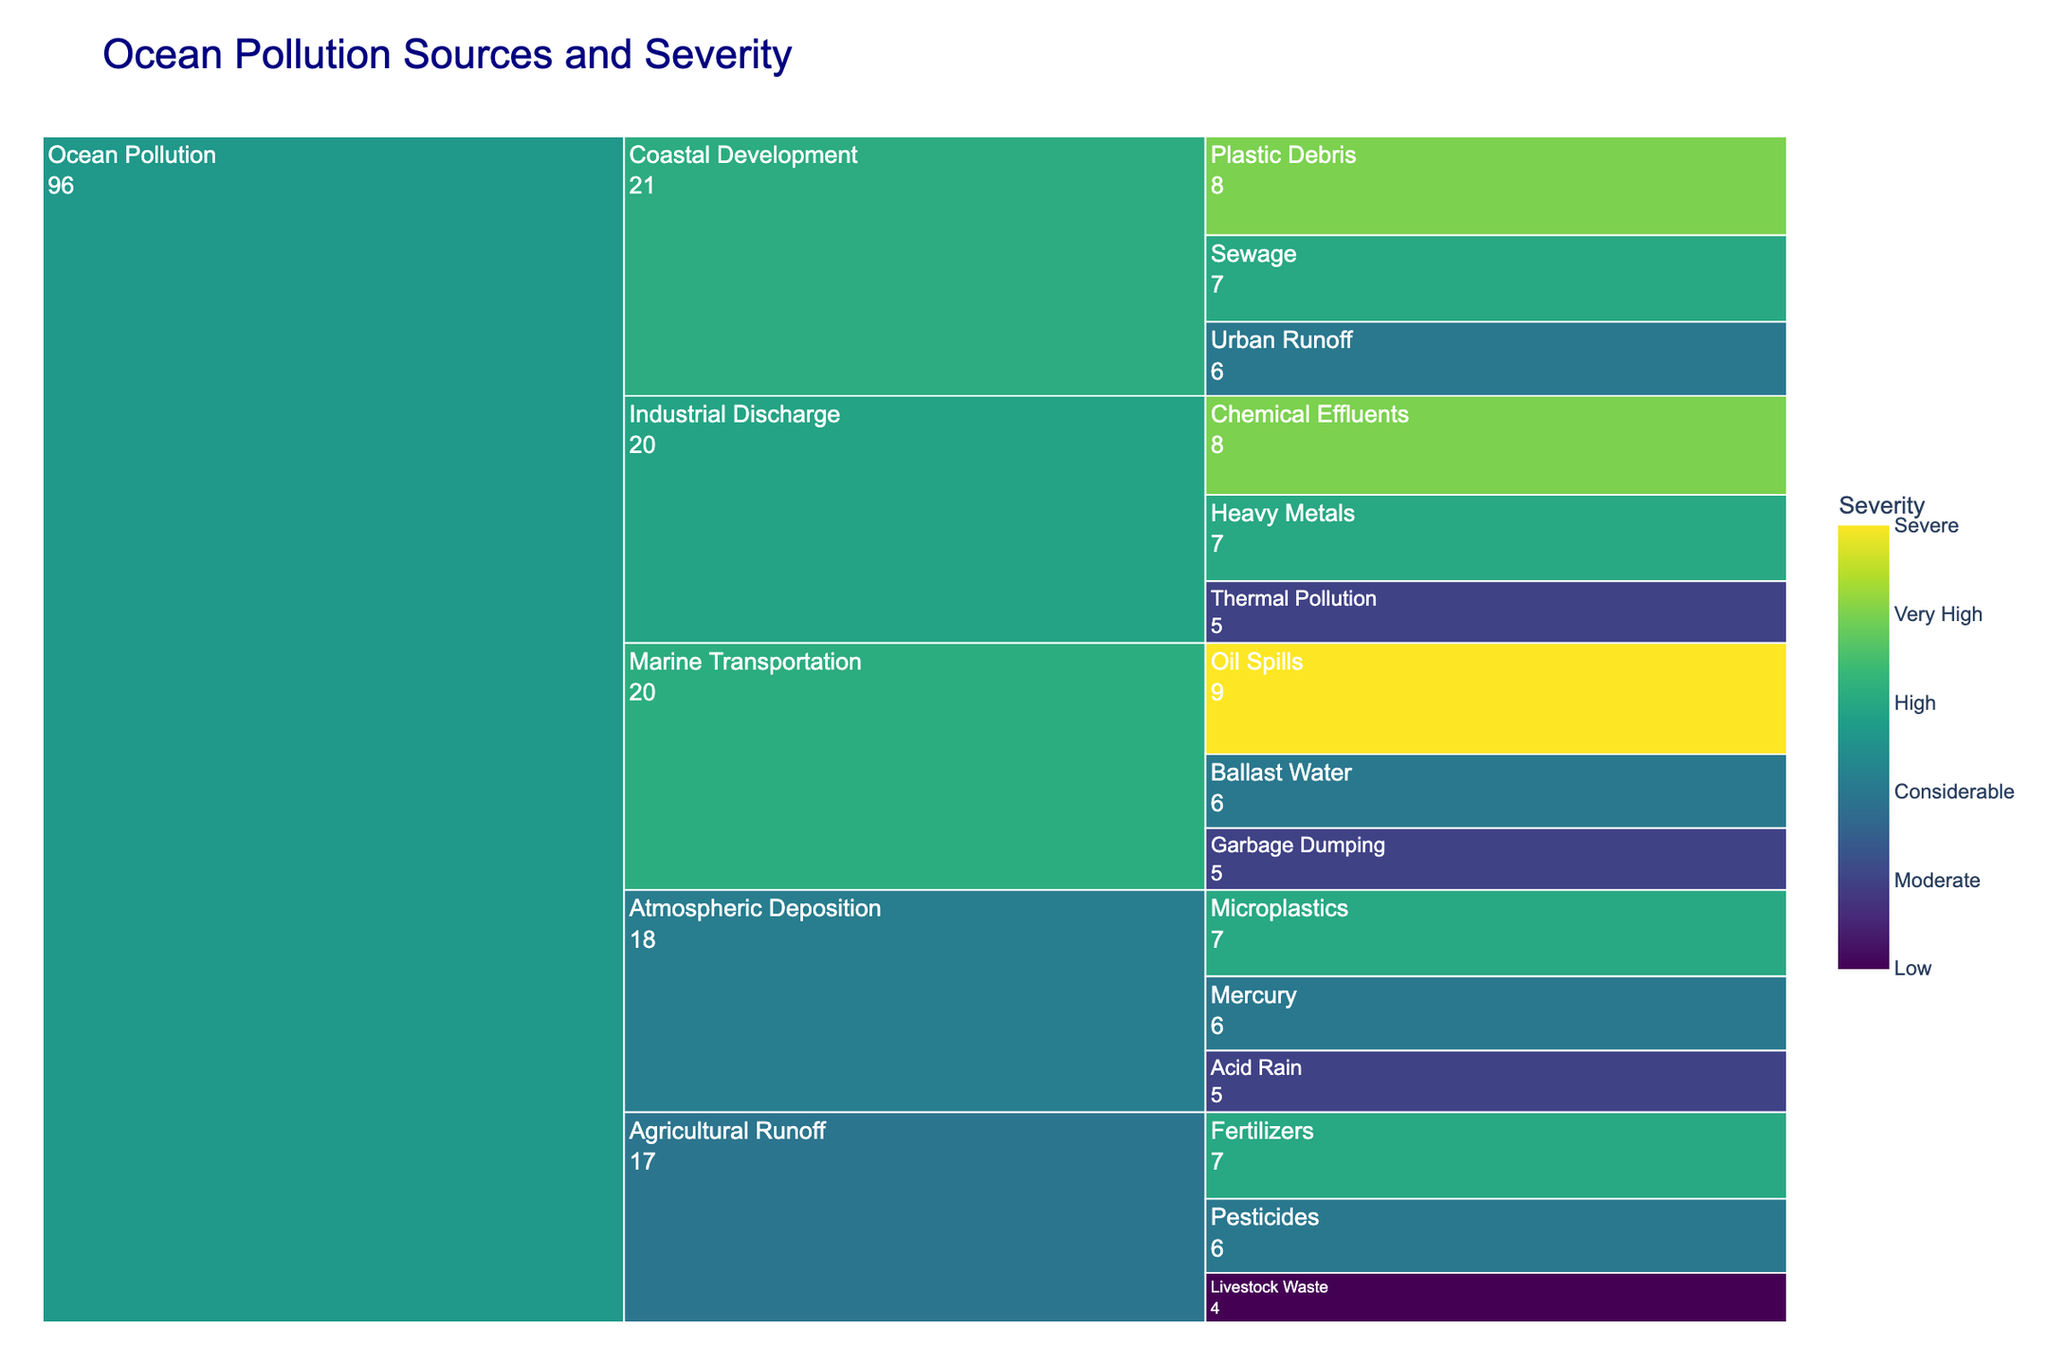What is the title of the chart? The title of the chart is displayed prominently at the top.
Answer: Ocean Pollution Sources and Severity Which subcategory under Ocean Pollution has the highest severity? Look for the subcategory with the highest severity value, as indicated by the darkest color and the highest number.
Answer: Marine Transportation (Oil Spills) How severe is marine transportation as a whole? Add the severity values for Oil Spills, Ballast Water, and Garbage Dumping.
Answer: 20 Which subcategory has a lower severity: Chemical Effluents or Ballast Water? Compare the severity values for these two types within their subcategories.
Answer: Ballast Water How does the severity of Pesticides compare to that of Microplastics? Compare the severity values directly.
Answer: Lower What is the total severity of all types under Industrial Discharge? Add the severity values for Chemical Effluents, Heavy Metals, and Thermal Pollution.
Answer: 20 Which subcategory under Coastal Development has the highest severity? Look for the highest severity value within Coastal Development.
Answer: Plastic Debris What is the most severe type of ocean pollution? Find the type with the highest severity value.
Answer: Oil Spills What is the severity of Atmospheric Deposition compared to Coastal Development? Sum the severity for Atmospheric Deposition (Acid Rain, Microplastics, Mercury) and Coastal Development (Sewage, Urban Runoff, Plastic Debris) and compare them.
Answer: Coastal Development has a higher total severity (21 vs. 18) How many types under Agricultural Runoff have a severity greater than 5? Identify the types under Agricultural Runoff and count those with severity greater than 5.
Answer: 2 